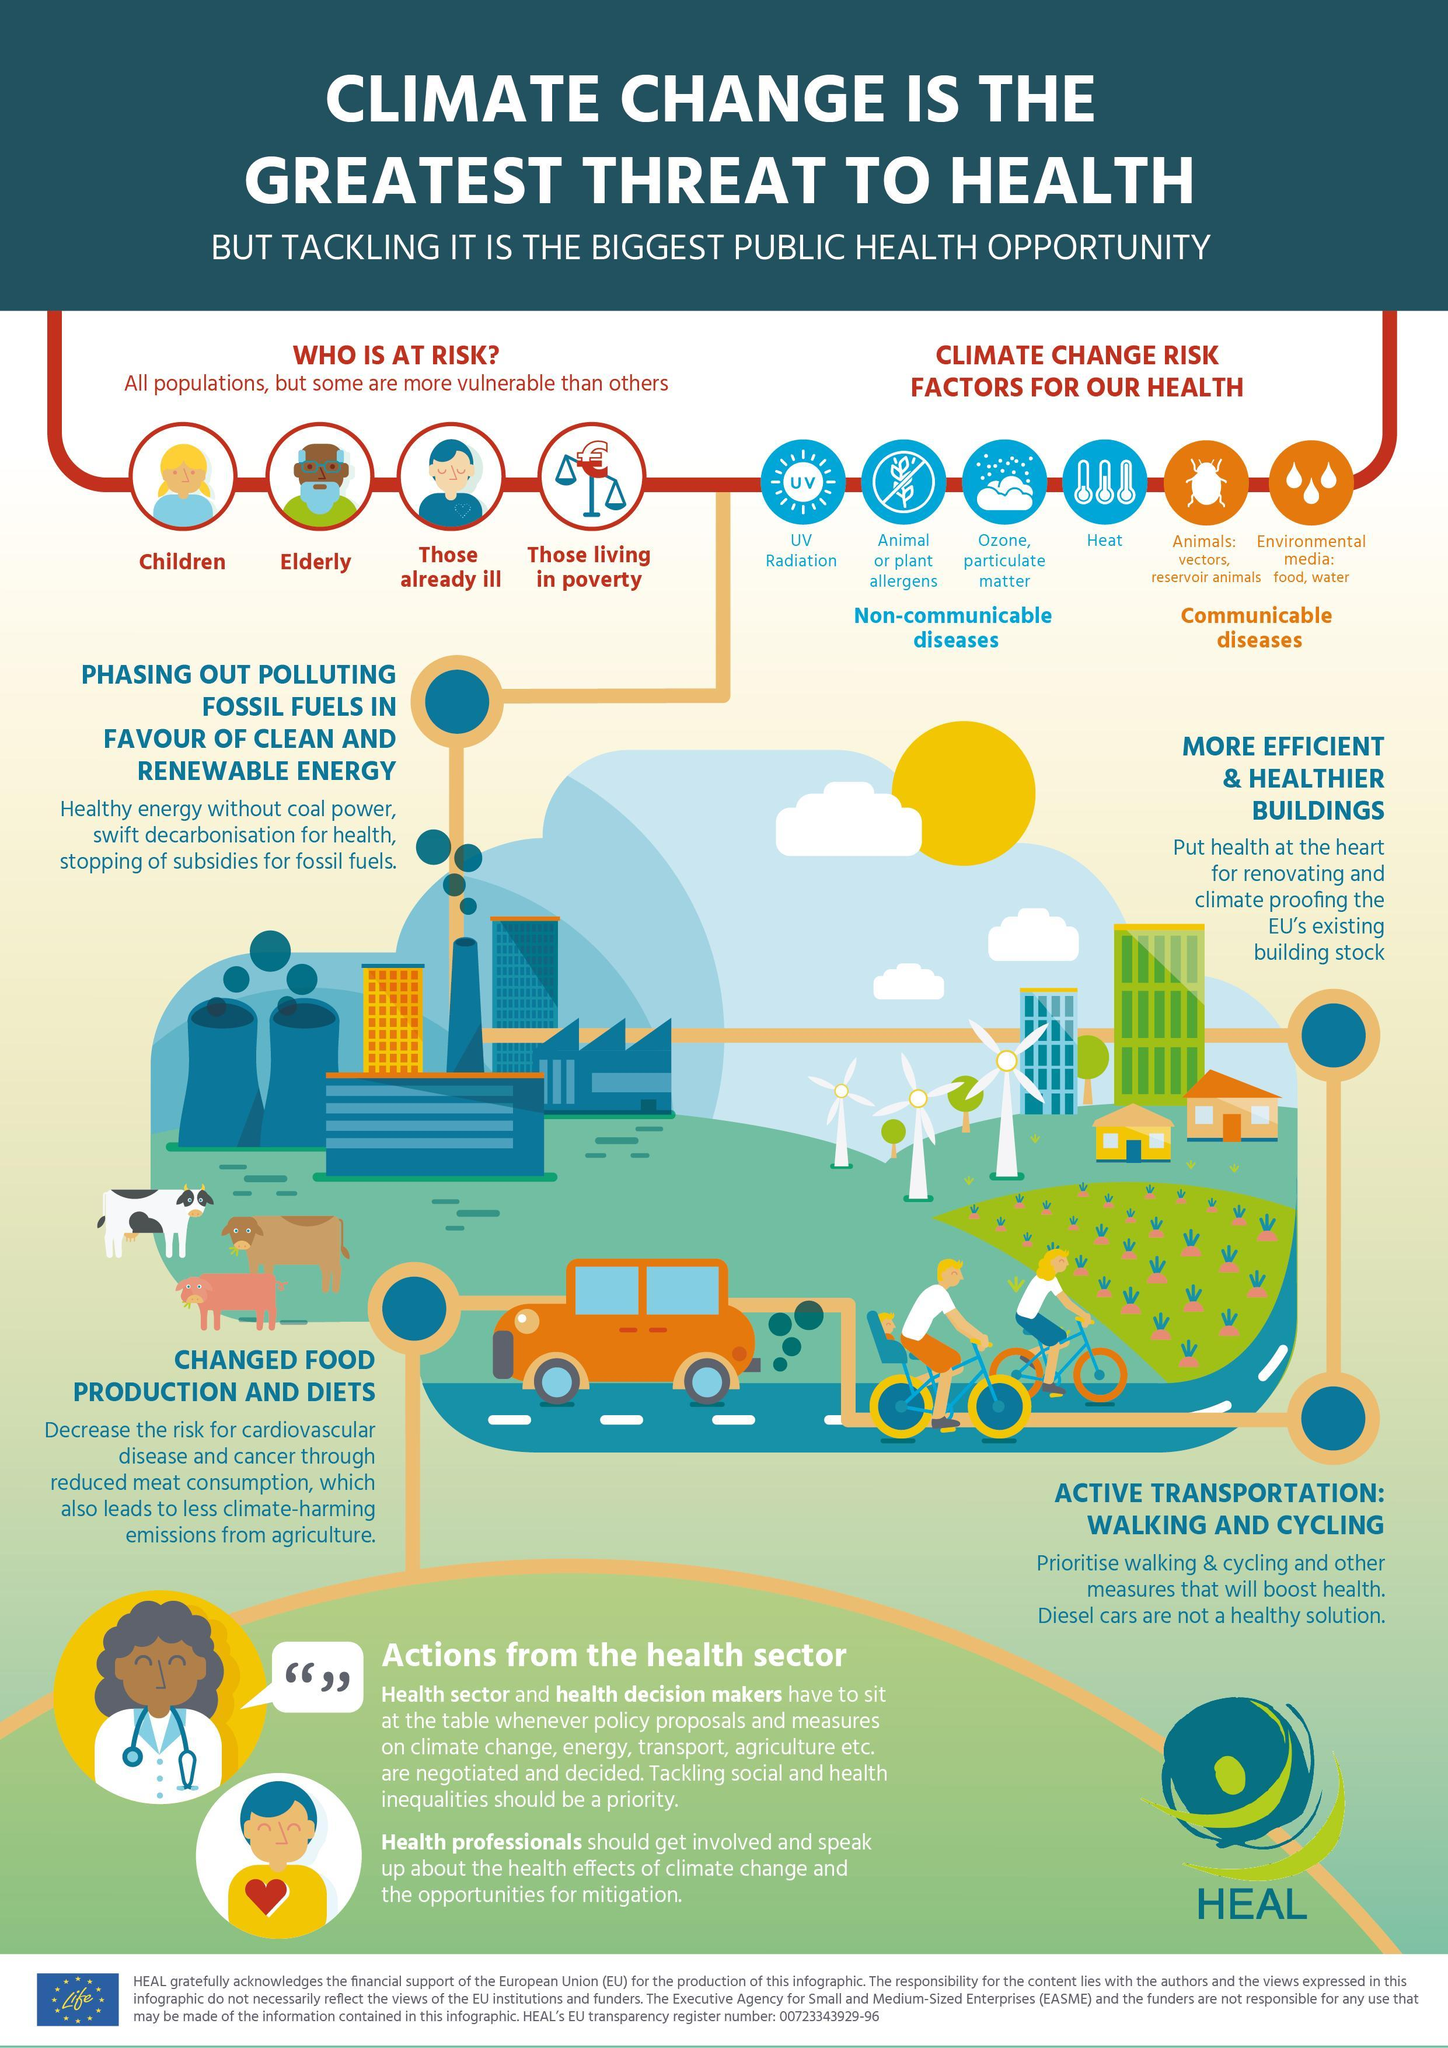How many risk factors are grouped as communicable diseases?
Answer the question with a short phrase. 2 Which group is mentioned second among the people who are at risk due to climate change? elderly How many risk factors are grouped as non-communicable diseases? 4 Which is the third group of people at risk due to climate change? Those already ill What is the fourth climate change risk factor mentioned? heat 